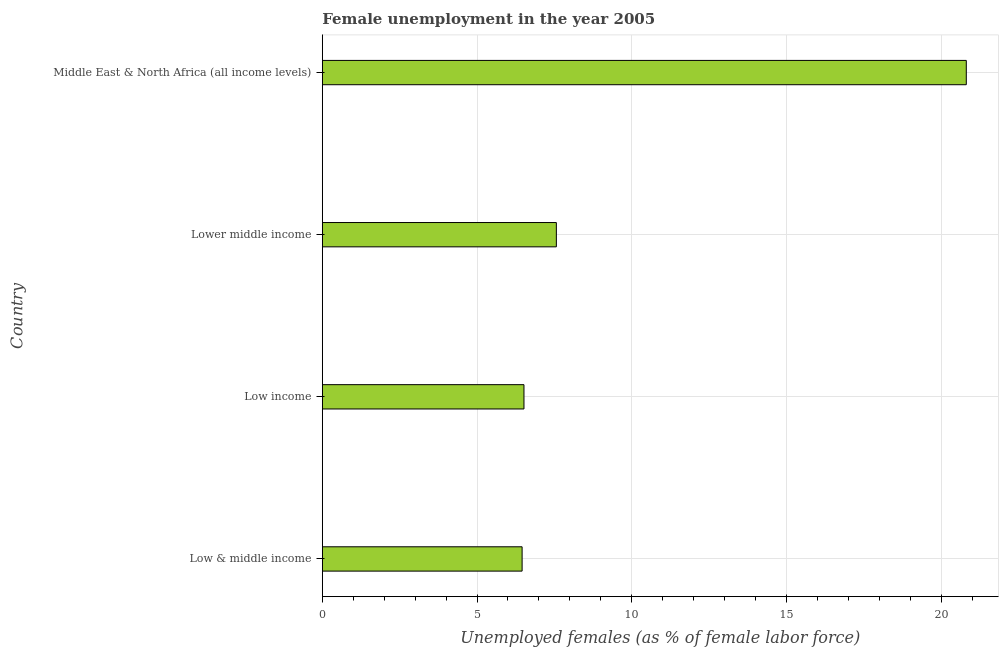Does the graph contain any zero values?
Your response must be concise. No. What is the title of the graph?
Offer a terse response. Female unemployment in the year 2005. What is the label or title of the X-axis?
Offer a terse response. Unemployed females (as % of female labor force). What is the unemployed females population in Low & middle income?
Ensure brevity in your answer.  6.46. Across all countries, what is the maximum unemployed females population?
Give a very brief answer. 20.81. Across all countries, what is the minimum unemployed females population?
Your answer should be compact. 6.46. In which country was the unemployed females population maximum?
Make the answer very short. Middle East & North Africa (all income levels). In which country was the unemployed females population minimum?
Ensure brevity in your answer.  Low & middle income. What is the sum of the unemployed females population?
Make the answer very short. 41.35. What is the difference between the unemployed females population in Low income and Middle East & North Africa (all income levels)?
Your response must be concise. -14.3. What is the average unemployed females population per country?
Provide a succinct answer. 10.34. What is the median unemployed females population?
Provide a succinct answer. 7.04. In how many countries, is the unemployed females population greater than 9 %?
Provide a short and direct response. 1. Is the unemployed females population in Low & middle income less than that in Low income?
Your response must be concise. Yes. What is the difference between the highest and the second highest unemployed females population?
Ensure brevity in your answer.  13.25. Is the sum of the unemployed females population in Low & middle income and Low income greater than the maximum unemployed females population across all countries?
Offer a terse response. No. What is the difference between the highest and the lowest unemployed females population?
Make the answer very short. 14.36. In how many countries, is the unemployed females population greater than the average unemployed females population taken over all countries?
Your response must be concise. 1. How many bars are there?
Keep it short and to the point. 4. How many countries are there in the graph?
Offer a terse response. 4. What is the difference between two consecutive major ticks on the X-axis?
Provide a short and direct response. 5. Are the values on the major ticks of X-axis written in scientific E-notation?
Your answer should be compact. No. What is the Unemployed females (as % of female labor force) of Low & middle income?
Keep it short and to the point. 6.46. What is the Unemployed females (as % of female labor force) in Low income?
Ensure brevity in your answer.  6.52. What is the Unemployed females (as % of female labor force) in Lower middle income?
Offer a terse response. 7.56. What is the Unemployed females (as % of female labor force) in Middle East & North Africa (all income levels)?
Keep it short and to the point. 20.81. What is the difference between the Unemployed females (as % of female labor force) in Low & middle income and Low income?
Make the answer very short. -0.06. What is the difference between the Unemployed females (as % of female labor force) in Low & middle income and Lower middle income?
Provide a succinct answer. -1.11. What is the difference between the Unemployed females (as % of female labor force) in Low & middle income and Middle East & North Africa (all income levels)?
Give a very brief answer. -14.36. What is the difference between the Unemployed females (as % of female labor force) in Low income and Lower middle income?
Your response must be concise. -1.05. What is the difference between the Unemployed females (as % of female labor force) in Low income and Middle East & North Africa (all income levels)?
Your answer should be compact. -14.3. What is the difference between the Unemployed females (as % of female labor force) in Lower middle income and Middle East & North Africa (all income levels)?
Provide a short and direct response. -13.25. What is the ratio of the Unemployed females (as % of female labor force) in Low & middle income to that in Lower middle income?
Provide a short and direct response. 0.85. What is the ratio of the Unemployed females (as % of female labor force) in Low & middle income to that in Middle East & North Africa (all income levels)?
Ensure brevity in your answer.  0.31. What is the ratio of the Unemployed females (as % of female labor force) in Low income to that in Lower middle income?
Your response must be concise. 0.86. What is the ratio of the Unemployed females (as % of female labor force) in Low income to that in Middle East & North Africa (all income levels)?
Your response must be concise. 0.31. What is the ratio of the Unemployed females (as % of female labor force) in Lower middle income to that in Middle East & North Africa (all income levels)?
Offer a terse response. 0.36. 